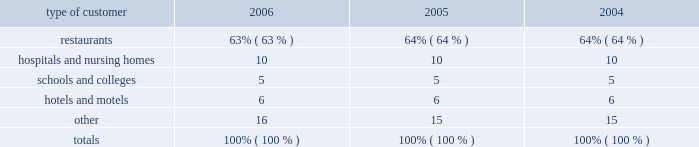Customers and products the foodservice industry consists of two major customer types 2014 2018 2018traditional 2019 2019 and 2018 2018chain restaurant . 2019 2019 traditional foodservice customers include restaurants , hospitals , schools , hotels and industrial caterers .
Sysco 2019s chain restaurant customers include regional and national hamburger , sandwich , pizza , chicken , steak and other chain operations .
Services to the company 2019s traditional foodservice and chain restaurant customers are supported by similar physical facilities , vehicles , material handling equipment and techniques , and administrative and operating staffs .
Products distributed by the company include a full line of frozen foods , such as meats , fully prepared entrees , fruits , vegetables and desserts ; a full line of canned and dry foods ; fresh meats ; imported specialties ; and fresh produce .
The company also supplies a wide variety of non-food items , including : paper products such as disposable napkins , plates and cups ; tableware such as china and silverware ; cookware such as pots , pans and utensils ; restaurant and kitchen equipment and supplies ; and cleaning supplies .
Sysco 2019s operating companies distribute nationally-branded merchandise , as well as products packaged under sysco 2019s private brands .
The company believes that prompt and accurate delivery of orders , close contact with customers and the ability to provide a full array of products and services to assist customers in their foodservice operations are of primary importance in the marketing and distribution of products to traditional customers .
Sysco 2019s operating companies offer daily delivery to certain customer locations and have the capability of delivering special orders on short notice .
Through the more than 13900 sales and marketing representatives and support staff of sysco and its operating companies , sysco stays informed of the needs of its customers and acquaints them with new products and services .
Sysco 2019s operating companies also provide ancillary services relating to foodservice distribution , such as providing customers with product usage reports and other data , menu-planning advice , food safety training and assistance in inventory control , as well as access to various third party services designed to add value to our customers 2019 businesses .
No single customer accounted for 10% ( 10 % ) or more of sysco 2019s total sales for its fiscal year ended july 1 , 2006 .
Sysco 2019s sales to chain restaurant customers consist of a variety of food products .
The company believes that consistent product quality and timely and accurate service are important factors in the selection of a chain restaurant supplier .
One chain restaurant customer ( wendy 2019s international , inc. ) accounted for 5% ( 5 % ) of sysco 2019s sales for its fiscal year ended july 1 , 2006 .
Although this customer represents approximately 37% ( 37 % ) of the sygma segment sales , the company does not believe that the loss of this customer would have a material adverse effect on sysco as a whole .
Based upon available information , the company estimates that sales by type of customer during the past three fiscal years were as follows: .
Restaurants **************************************************************** 63% ( 63 % ) 64% ( 64 % ) 64% ( 64 % ) hospitals and nursing homes *************************************************** 10 10 10 schools and colleges ********************************************************* 5 5 5 hotels and motels *********************************************************** 6 6 6 other********************************************************************* 16 15 15 totals ****************************************************************** 100% ( 100 % ) 100% ( 100 % ) 100% ( 100 % ) sources of supply sysco purchases from thousands of suppliers , none of which individually accounts for more than 10% ( 10 % ) of the company 2019s purchases .
These suppliers consist generally of large corporations selling brand name and private label merchandise and independent regional brand and private label processors and packers .
Generally , purchasing is carried out through centrally developed purchasing programs and direct purchasing programs established by the company 2019s various operating companies .
The company continually develops relationships with suppliers but has no material long-term purchase commitments with any supplier .
In the second quarter of fiscal 2002 , sysco began a project to restructure its supply chain ( national supply chain project ) .
This project is intended to increase profitability by lowering aggregate inventory levels , operating costs , and future facility expansion needs at sysco 2019s broadline operating companies while providing greater value to our suppliers and customers .
%%transmsg*** transmitting job : h39408 pcn : 004000000 *** %%pcmsg|2 |00010|yes|no|09/06/2006 17:07|0|1|page is valid , no graphics -- color : n| .
What was the change in percentage sales to restaurants from 2005 to 2006? 
Computations: (63% - 64%)
Answer: -0.01. 